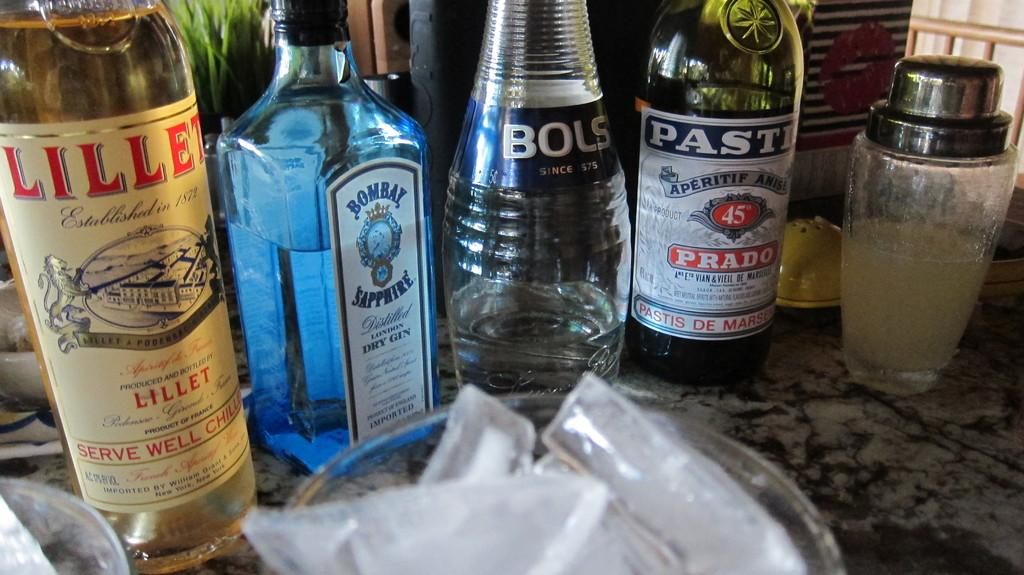<image>
Give a short and clear explanation of the subsequent image. The cocktail contains four types of alcohol, including Prado. 